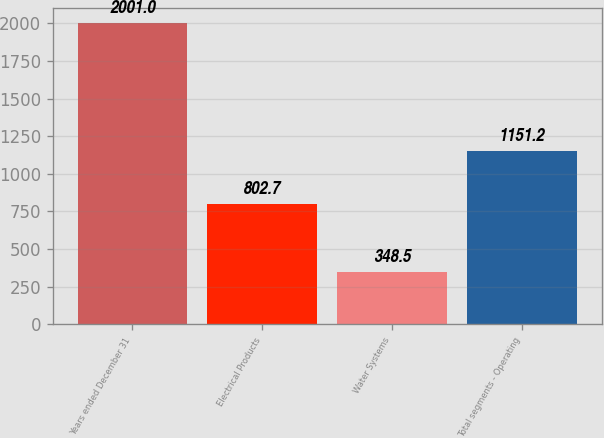Convert chart to OTSL. <chart><loc_0><loc_0><loc_500><loc_500><bar_chart><fcel>Years ended December 31<fcel>Electrical Products<fcel>Water Systems<fcel>Total segments - Operating<nl><fcel>2001<fcel>802.7<fcel>348.5<fcel>1151.2<nl></chart> 